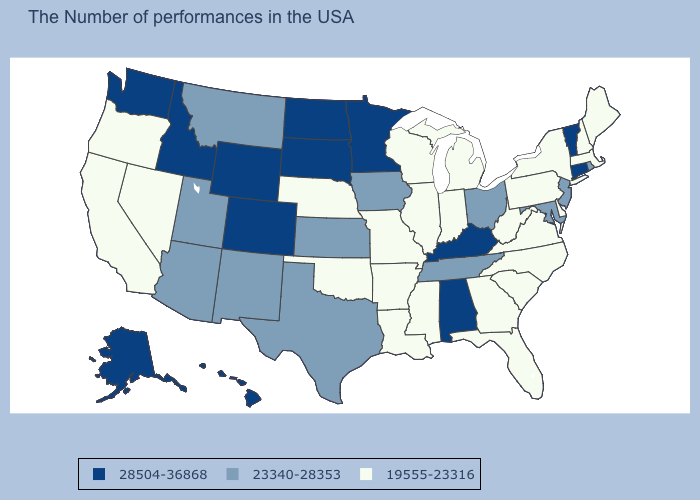Does Nevada have the same value as Tennessee?
Keep it brief. No. Which states have the lowest value in the USA?
Short answer required. Maine, Massachusetts, New Hampshire, New York, Delaware, Pennsylvania, Virginia, North Carolina, South Carolina, West Virginia, Florida, Georgia, Michigan, Indiana, Wisconsin, Illinois, Mississippi, Louisiana, Missouri, Arkansas, Nebraska, Oklahoma, Nevada, California, Oregon. What is the highest value in the USA?
Write a very short answer. 28504-36868. How many symbols are there in the legend?
Give a very brief answer. 3. Name the states that have a value in the range 28504-36868?
Quick response, please. Vermont, Connecticut, Kentucky, Alabama, Minnesota, South Dakota, North Dakota, Wyoming, Colorado, Idaho, Washington, Alaska, Hawaii. Name the states that have a value in the range 19555-23316?
Write a very short answer. Maine, Massachusetts, New Hampshire, New York, Delaware, Pennsylvania, Virginia, North Carolina, South Carolina, West Virginia, Florida, Georgia, Michigan, Indiana, Wisconsin, Illinois, Mississippi, Louisiana, Missouri, Arkansas, Nebraska, Oklahoma, Nevada, California, Oregon. What is the value of North Carolina?
Quick response, please. 19555-23316. Name the states that have a value in the range 19555-23316?
Keep it brief. Maine, Massachusetts, New Hampshire, New York, Delaware, Pennsylvania, Virginia, North Carolina, South Carolina, West Virginia, Florida, Georgia, Michigan, Indiana, Wisconsin, Illinois, Mississippi, Louisiana, Missouri, Arkansas, Nebraska, Oklahoma, Nevada, California, Oregon. Name the states that have a value in the range 19555-23316?
Give a very brief answer. Maine, Massachusetts, New Hampshire, New York, Delaware, Pennsylvania, Virginia, North Carolina, South Carolina, West Virginia, Florida, Georgia, Michigan, Indiana, Wisconsin, Illinois, Mississippi, Louisiana, Missouri, Arkansas, Nebraska, Oklahoma, Nevada, California, Oregon. Among the states that border Tennessee , which have the highest value?
Write a very short answer. Kentucky, Alabama. Among the states that border Colorado , which have the lowest value?
Quick response, please. Nebraska, Oklahoma. Which states have the highest value in the USA?
Give a very brief answer. Vermont, Connecticut, Kentucky, Alabama, Minnesota, South Dakota, North Dakota, Wyoming, Colorado, Idaho, Washington, Alaska, Hawaii. Name the states that have a value in the range 23340-28353?
Give a very brief answer. Rhode Island, New Jersey, Maryland, Ohio, Tennessee, Iowa, Kansas, Texas, New Mexico, Utah, Montana, Arizona. What is the lowest value in the MidWest?
Concise answer only. 19555-23316. Does Tennessee have the highest value in the USA?
Short answer required. No. 